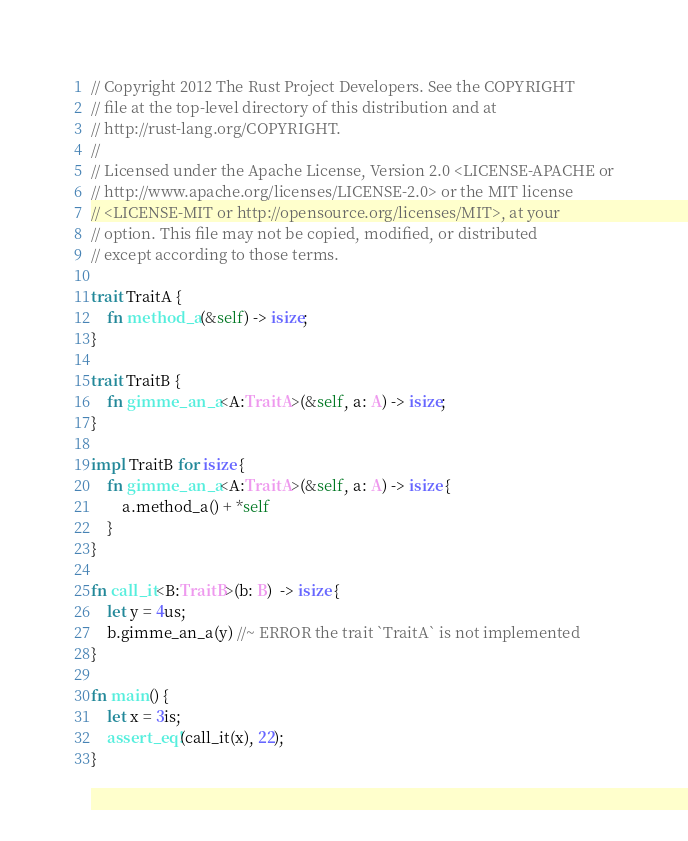Convert code to text. <code><loc_0><loc_0><loc_500><loc_500><_Rust_>// Copyright 2012 The Rust Project Developers. See the COPYRIGHT
// file at the top-level directory of this distribution and at
// http://rust-lang.org/COPYRIGHT.
//
// Licensed under the Apache License, Version 2.0 <LICENSE-APACHE or
// http://www.apache.org/licenses/LICENSE-2.0> or the MIT license
// <LICENSE-MIT or http://opensource.org/licenses/MIT>, at your
// option. This file may not be copied, modified, or distributed
// except according to those terms.

trait TraitA {
    fn method_a(&self) -> isize;
}

trait TraitB {
    fn gimme_an_a<A:TraitA>(&self, a: A) -> isize;
}

impl TraitB for isize {
    fn gimme_an_a<A:TraitA>(&self, a: A) -> isize {
        a.method_a() + *self
    }
}

fn call_it<B:TraitB>(b: B)  -> isize {
    let y = 4us;
    b.gimme_an_a(y) //~ ERROR the trait `TraitA` is not implemented
}

fn main() {
    let x = 3is;
    assert_eq!(call_it(x), 22);
}
</code> 